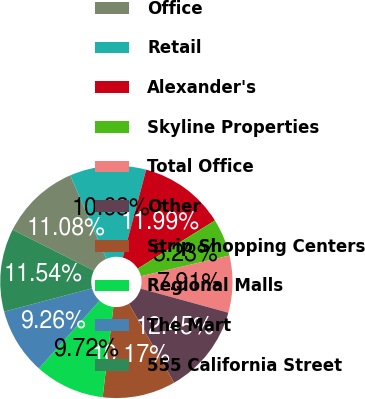<chart> <loc_0><loc_0><loc_500><loc_500><pie_chart><fcel>Office<fcel>Retail<fcel>Alexander's<fcel>Skyline Properties<fcel>Total Office<fcel>Other<fcel>Strip Shopping Centers<fcel>Regional Malls<fcel>The Mart<fcel>555 California Street<nl><fcel>11.08%<fcel>10.63%<fcel>11.99%<fcel>5.23%<fcel>7.91%<fcel>12.45%<fcel>10.17%<fcel>9.72%<fcel>9.26%<fcel>11.54%<nl></chart> 